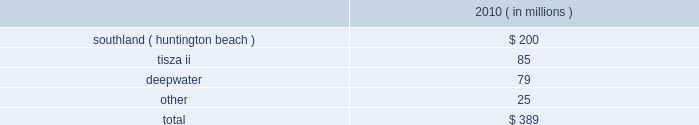The aes corporation notes to consolidated financial statements 2014 ( continued ) december 31 , 2011 , 2010 , and 2009 may require the government to acquire an ownership interest and the current expectation of future losses .
Our evaluation indicated that the long-lived assets were no longer recoverable and , accordingly , they were written down to their estimated fair value of $ 24 million based on a discounted cash flow analysis .
The long-lived assets had a carrying amount of $ 66 million prior to the recognition of asset impairment expense .
Kelanitissa is a build- operate-transfer ( bot ) generation facility and payments under its ppa are scheduled to decline over the ppa term .
It is possible that further impairment charges may be required in the future as kelanitissa gets closer to the bot date .
Kelanitissa is reported in the asia generation reportable segment .
Asset impairment expense for the year ended december 31 , 2010 consisted of : ( in millions ) .
Southland 2014in september 2010 , a new environmental policy on the use of ocean water to cool generation facilities was issued in california that requires generation plants to comply with the policy by december 31 , 2020 and would require significant capital expenditure or plants 2019 shutdown .
The company 2019s huntington beach gas-fired generation facility in california , which is part of aes 2019 southland business , was impacted by the new policy .
The company performed an asset impairment test and determined the fair value of the asset group using a discounted cash flow analysis .
The carrying value of the asset group of $ 288 million exceeded the fair value of $ 88 million resulting in the recognition of asset impairment expense of $ 200 million for the year ended december 31 , 2010 .
Southland is reported in the north america generation reportable segment .
Tisza ii 2014during the third quarter of 2010 , the company entered into annual negotiations with the offtaker of tisza ii .
As a result of these preliminary negotiations , as well as the further deterioration of the economic environment in hungary , the company determined that an indicator of impairment existed at september 30 , 2010 .
Thus , the company performed an asset impairment test and determined that based on the undiscounted cash flow analysis , the carrying amount of the tisza ii asset group was not recoverable .
The fair value of the asset group was then determined using a discounted cash flow analysis .
The carrying value of the tisza ii asset group of $ 160 million exceeded the fair value of $ 75 million resulting in the recognition of asset impairment expense of $ 85 million during the year ended december 31 , 2010 .
Deepwater 2014in 2010 , deepwater , our 160 mw petcoke-fired merchant power plant located in texas , experienced deteriorating market conditions due to increasing petcoke prices and diminishing power prices .
As a result , deepwater incurred operating losses and was shut down from time to time to avoid negative operating margin .
In the fourth quarter of 2010 , management concluded that , on an undiscounted cash flow basis , the carrying amount of the asset group was no longer recoverable .
The fair value of deepwater was determined using a discounted cash flow analysis and $ 79 million of impairment expense was recognized .
Deepwater is reported in the north america generation reportable segment. .
For the huntington beach facility in california , the write down was what percent of the total carrying value? 
Computations: (200 / 288)
Answer: 0.69444. 